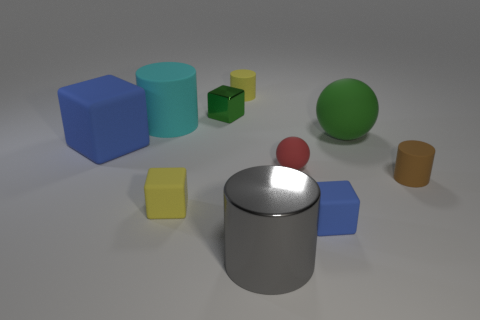Subtract all tiny blocks. How many blocks are left? 1 Subtract all purple balls. How many blue cubes are left? 2 Subtract all yellow cylinders. How many cylinders are left? 3 Subtract all cylinders. How many objects are left? 6 Subtract all big things. Subtract all big purple metallic cylinders. How many objects are left? 6 Add 5 small yellow blocks. How many small yellow blocks are left? 6 Add 5 small metallic blocks. How many small metallic blocks exist? 6 Subtract 2 blue cubes. How many objects are left? 8 Subtract all gray cylinders. Subtract all blue blocks. How many cylinders are left? 3 